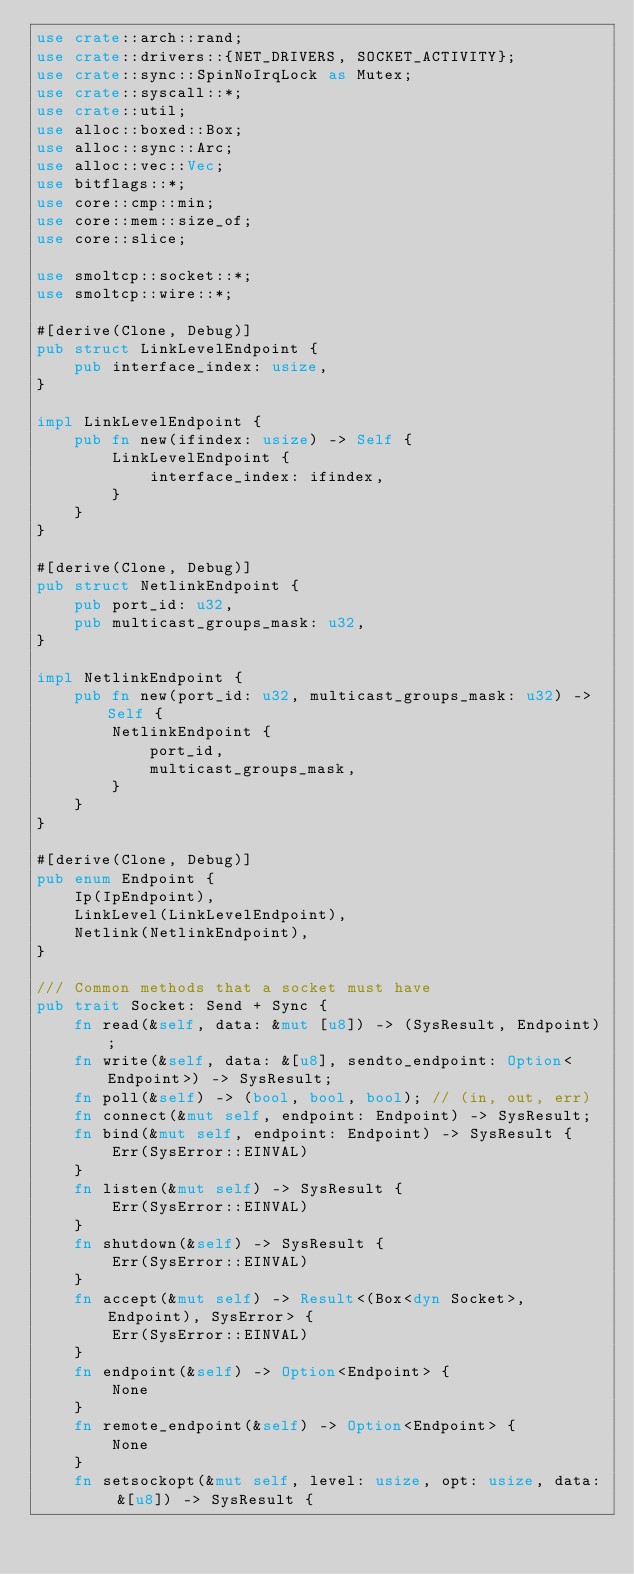Convert code to text. <code><loc_0><loc_0><loc_500><loc_500><_Rust_>use crate::arch::rand;
use crate::drivers::{NET_DRIVERS, SOCKET_ACTIVITY};
use crate::sync::SpinNoIrqLock as Mutex;
use crate::syscall::*;
use crate::util;
use alloc::boxed::Box;
use alloc::sync::Arc;
use alloc::vec::Vec;
use bitflags::*;
use core::cmp::min;
use core::mem::size_of;
use core::slice;

use smoltcp::socket::*;
use smoltcp::wire::*;

#[derive(Clone, Debug)]
pub struct LinkLevelEndpoint {
    pub interface_index: usize,
}

impl LinkLevelEndpoint {
    pub fn new(ifindex: usize) -> Self {
        LinkLevelEndpoint {
            interface_index: ifindex,
        }
    }
}

#[derive(Clone, Debug)]
pub struct NetlinkEndpoint {
    pub port_id: u32,
    pub multicast_groups_mask: u32,
}

impl NetlinkEndpoint {
    pub fn new(port_id: u32, multicast_groups_mask: u32) -> Self {
        NetlinkEndpoint {
            port_id,
            multicast_groups_mask,
        }
    }
}

#[derive(Clone, Debug)]
pub enum Endpoint {
    Ip(IpEndpoint),
    LinkLevel(LinkLevelEndpoint),
    Netlink(NetlinkEndpoint),
}

/// Common methods that a socket must have
pub trait Socket: Send + Sync {
    fn read(&self, data: &mut [u8]) -> (SysResult, Endpoint);
    fn write(&self, data: &[u8], sendto_endpoint: Option<Endpoint>) -> SysResult;
    fn poll(&self) -> (bool, bool, bool); // (in, out, err)
    fn connect(&mut self, endpoint: Endpoint) -> SysResult;
    fn bind(&mut self, endpoint: Endpoint) -> SysResult {
        Err(SysError::EINVAL)
    }
    fn listen(&mut self) -> SysResult {
        Err(SysError::EINVAL)
    }
    fn shutdown(&self) -> SysResult {
        Err(SysError::EINVAL)
    }
    fn accept(&mut self) -> Result<(Box<dyn Socket>, Endpoint), SysError> {
        Err(SysError::EINVAL)
    }
    fn endpoint(&self) -> Option<Endpoint> {
        None
    }
    fn remote_endpoint(&self) -> Option<Endpoint> {
        None
    }
    fn setsockopt(&mut self, level: usize, opt: usize, data: &[u8]) -> SysResult {</code> 